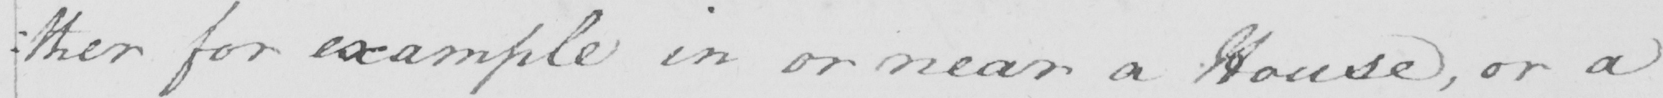Transcribe the text shown in this historical manuscript line. : ther for example in or near a House , or a 